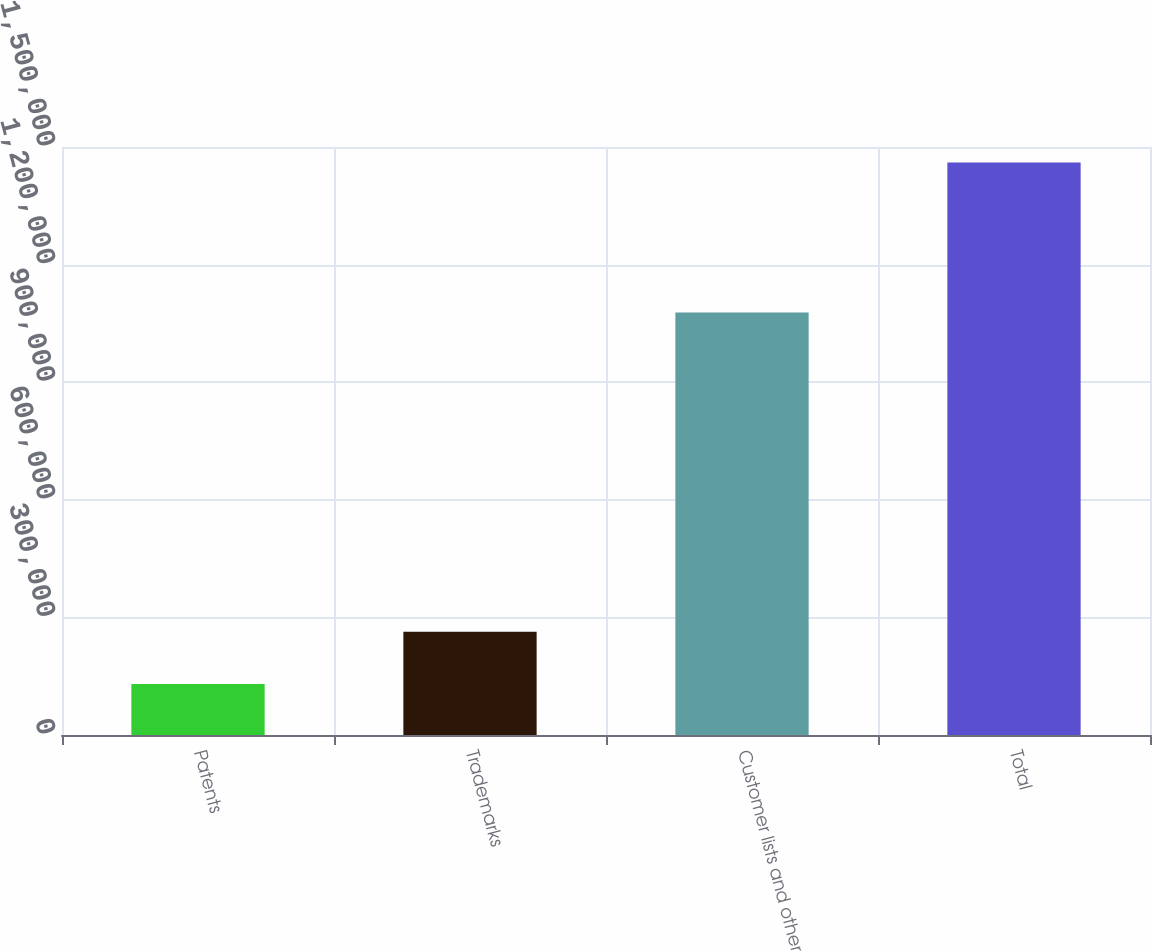Convert chart. <chart><loc_0><loc_0><loc_500><loc_500><bar_chart><fcel>Patents<fcel>Trademarks<fcel>Customer lists and other<fcel>Total<nl><fcel>130233<fcel>263250<fcel>1.07778e+06<fcel>1.4604e+06<nl></chart> 